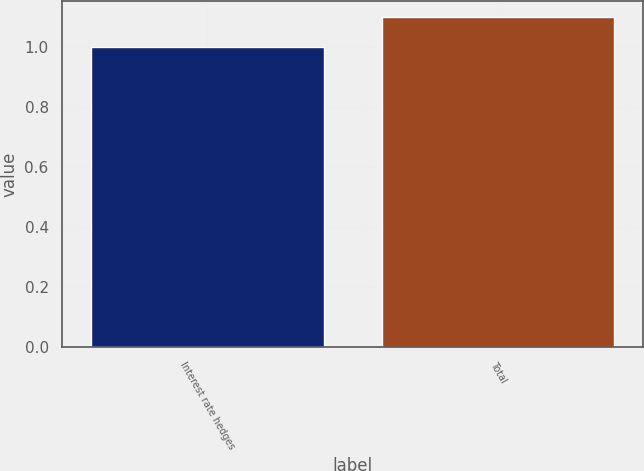Convert chart. <chart><loc_0><loc_0><loc_500><loc_500><bar_chart><fcel>Interest rate hedges<fcel>Total<nl><fcel>1<fcel>1.1<nl></chart> 